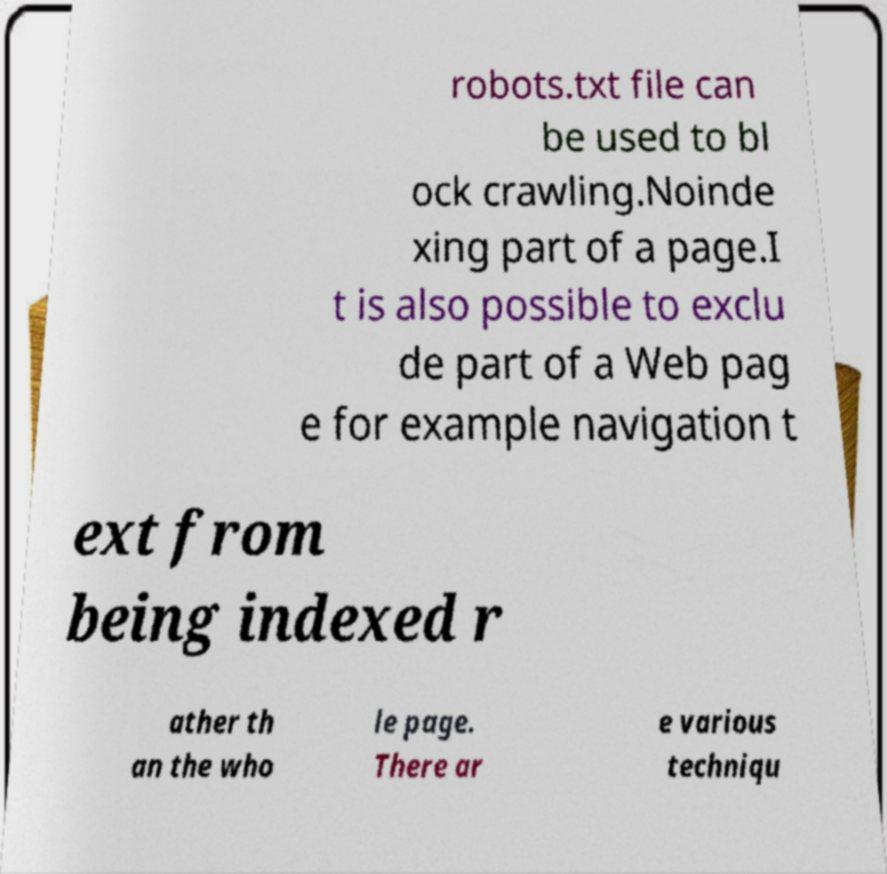I need the written content from this picture converted into text. Can you do that? robots.txt file can be used to bl ock crawling.Noinde xing part of a page.I t is also possible to exclu de part of a Web pag e for example navigation t ext from being indexed r ather th an the who le page. There ar e various techniqu 